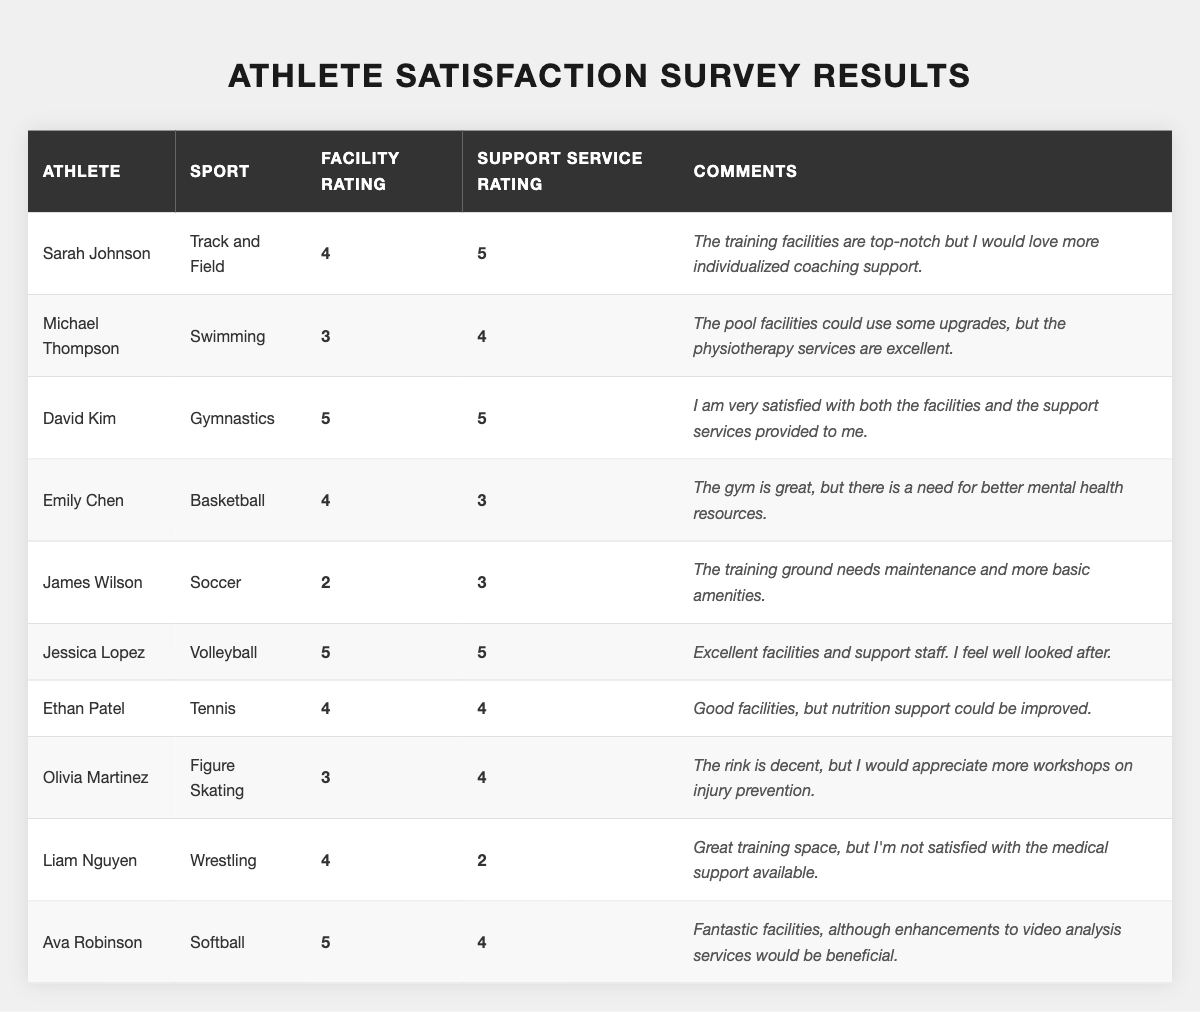What is the highest facility rating given by an athlete? By reviewing the table, the highest facility rating noted is 5, which is given by David Kim and Jessica Lopez.
Answer: 5 Which athlete mentioned the need for better mental health resources? In the comments section, Emily Chen stated there is a need for better mental health resources.
Answer: Emily Chen What is the average support service rating for all athletes? The total of the support service ratings is (5 + 4 + 5 + 3 + 3 + 5 + 4 + 4 + 2 + 4) = 43. There are 10 athletes, so the average is 43/10 = 4.3.
Answer: 4.3 Did any athlete rate their facility and support service both as 5? Yes, both David Kim and Jessica Lopez rated their facility and support services as 5.
Answer: Yes Which sport had an athlete who rated facility support as the lowest? James Wilson in Soccer rated 2 for facility support, which is the lowest in the table.
Answer: Soccer What percentage of athletes rated their training facilities as 4 or higher? There are 7 out of 10 athletes who rated their facilities as 4 or higher (Sarah, David, Emily, Jessica, Ethan, Liam, Ava). Thus, the percentage is (7/10)*100 = 70%.
Answer: 70% Which athlete mentioned excellent physiotherapy services? Michael Thompson commented on the excellent physiotherapy services while mentioning the pool facilities needing upgrades.
Answer: Michael Thompson How many athletes are not satisfied with the medical support available? Liam Nguyen rated support services as 2, indicating dissatisfaction with medical support.
Answer: 1 athlete What does Jessica Lopez think of the support staff? Jessica Lopez expressed satisfaction in her comments stating, "I feel well looked after," indicating a positive view of the support staff.
Answer: Positive What is the difference between the highest and lowest facility ratings? The highest facility rating is 5 (David Kim and Jessica Lopez), and the lowest is 2 (James Wilson), resulting in a difference of 5 - 2 = 3.
Answer: 3 